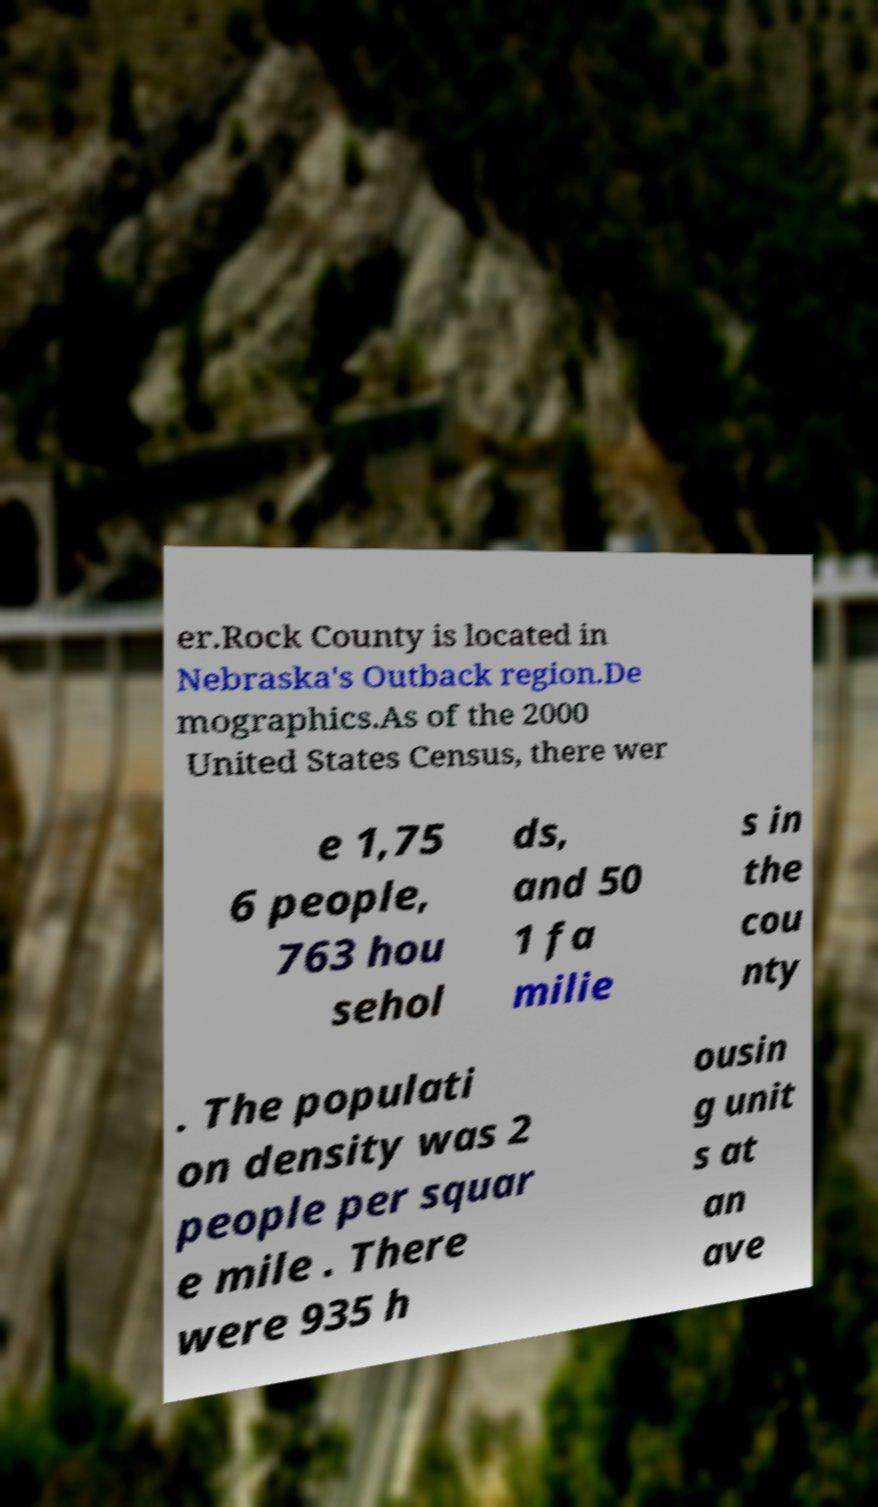What messages or text are displayed in this image? I need them in a readable, typed format. er.Rock County is located in Nebraska's Outback region.De mographics.As of the 2000 United States Census, there wer e 1,75 6 people, 763 hou sehol ds, and 50 1 fa milie s in the cou nty . The populati on density was 2 people per squar e mile . There were 935 h ousin g unit s at an ave 